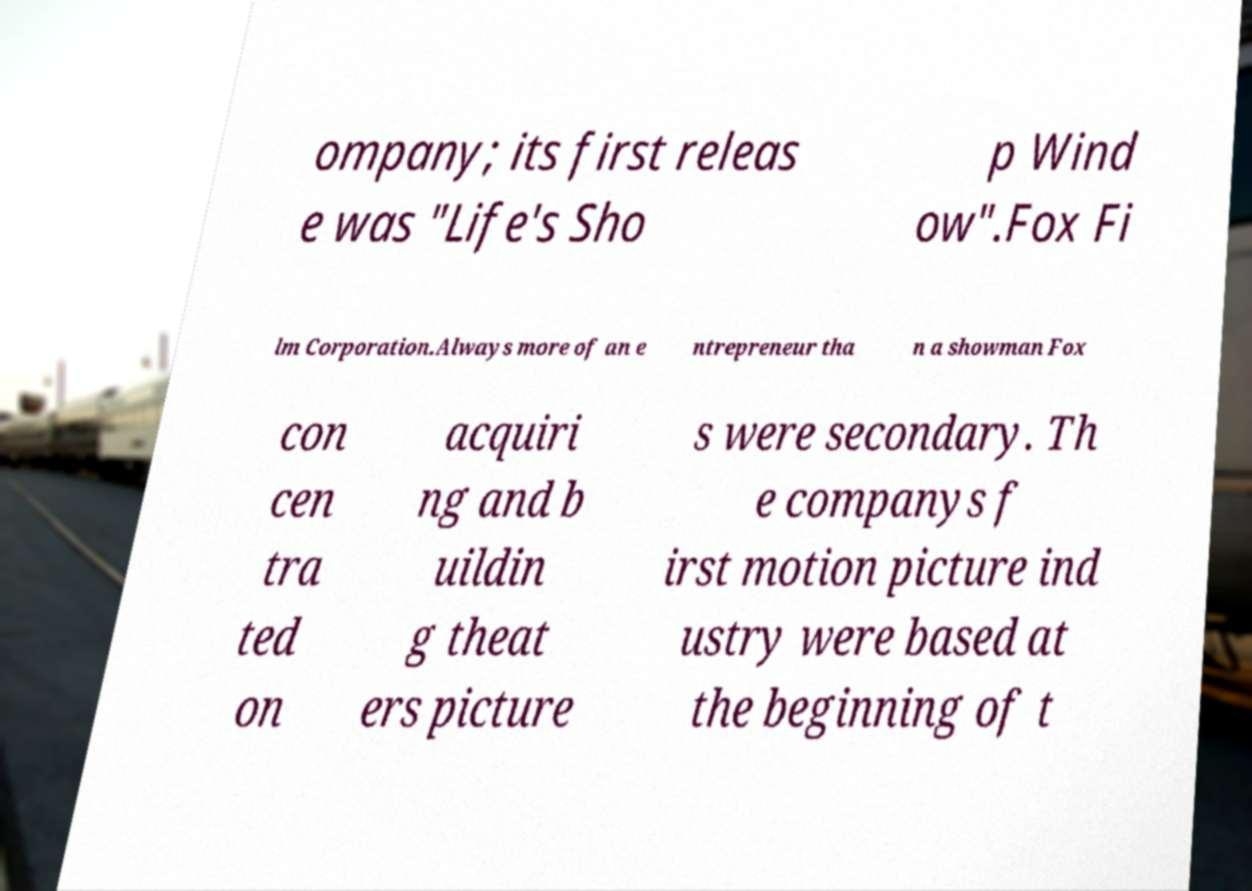What messages or text are displayed in this image? I need them in a readable, typed format. ompany; its first releas e was "Life's Sho p Wind ow".Fox Fi lm Corporation.Always more of an e ntrepreneur tha n a showman Fox con cen tra ted on acquiri ng and b uildin g theat ers picture s were secondary. Th e companys f irst motion picture ind ustry were based at the beginning of t 